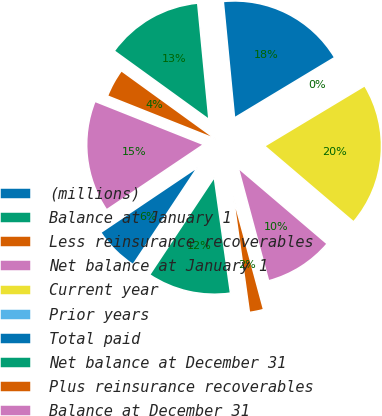<chart> <loc_0><loc_0><loc_500><loc_500><pie_chart><fcel>(millions)<fcel>Balance at January 1<fcel>Less reinsurance recoverables<fcel>Net balance at January 1<fcel>Current year<fcel>Prior years<fcel>Total paid<fcel>Net balance at December 31<fcel>Plus reinsurance recoverables<fcel>Balance at December 31<nl><fcel>6.25%<fcel>11.54%<fcel>1.97%<fcel>9.58%<fcel>19.86%<fcel>0.01%<fcel>17.9%<fcel>13.5%<fcel>3.94%<fcel>15.46%<nl></chart> 